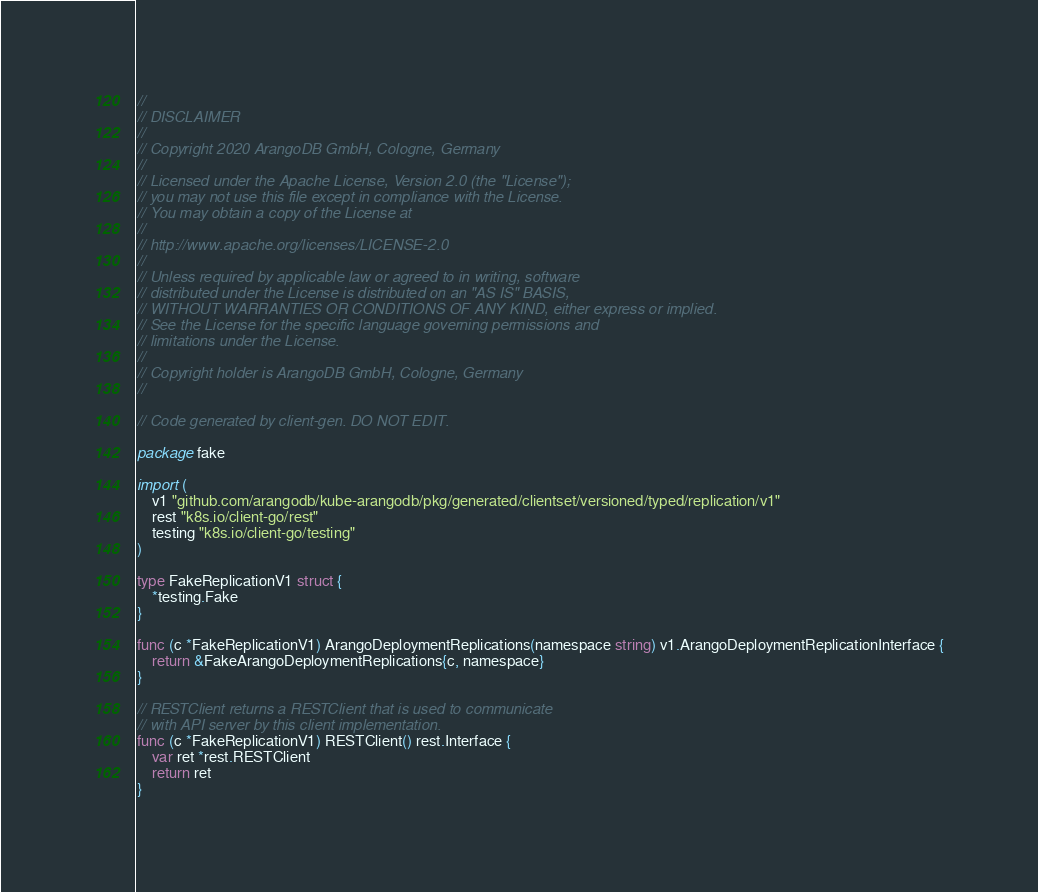<code> <loc_0><loc_0><loc_500><loc_500><_Go_>//
// DISCLAIMER
//
// Copyright 2020 ArangoDB GmbH, Cologne, Germany
//
// Licensed under the Apache License, Version 2.0 (the "License");
// you may not use this file except in compliance with the License.
// You may obtain a copy of the License at
//
// http://www.apache.org/licenses/LICENSE-2.0
//
// Unless required by applicable law or agreed to in writing, software
// distributed under the License is distributed on an "AS IS" BASIS,
// WITHOUT WARRANTIES OR CONDITIONS OF ANY KIND, either express or implied.
// See the License for the specific language governing permissions and
// limitations under the License.
//
// Copyright holder is ArangoDB GmbH, Cologne, Germany
//

// Code generated by client-gen. DO NOT EDIT.

package fake

import (
	v1 "github.com/arangodb/kube-arangodb/pkg/generated/clientset/versioned/typed/replication/v1"
	rest "k8s.io/client-go/rest"
	testing "k8s.io/client-go/testing"
)

type FakeReplicationV1 struct {
	*testing.Fake
}

func (c *FakeReplicationV1) ArangoDeploymentReplications(namespace string) v1.ArangoDeploymentReplicationInterface {
	return &FakeArangoDeploymentReplications{c, namespace}
}

// RESTClient returns a RESTClient that is used to communicate
// with API server by this client implementation.
func (c *FakeReplicationV1) RESTClient() rest.Interface {
	var ret *rest.RESTClient
	return ret
}
</code> 